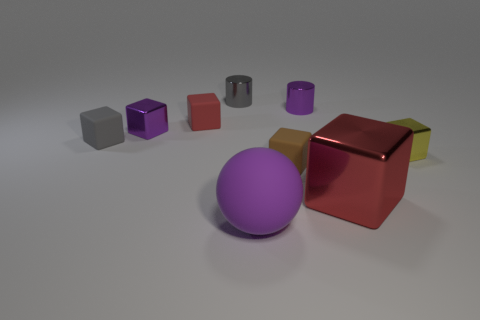Is the big rubber ball the same color as the large metallic thing?
Make the answer very short. No. Are there fewer small gray things that are on the left side of the yellow metallic object than big purple balls?
Ensure brevity in your answer.  No. There is a thing right of the big red metal object; what is its color?
Provide a short and direct response. Yellow. There is a brown rubber thing; what shape is it?
Your answer should be compact. Cube. Is there a small gray matte cube behind the large shiny object on the left side of the tiny cube right of the big cube?
Offer a very short reply. Yes. The metallic block that is in front of the small brown matte object on the right side of the tiny metal cylinder that is to the left of the big ball is what color?
Provide a succinct answer. Red. There is a small brown object that is the same shape as the small yellow metallic object; what is its material?
Make the answer very short. Rubber. What size is the purple shiny cylinder right of the purple metal cube that is behind the tiny brown matte thing?
Your answer should be compact. Small. There is a small block that is in front of the small yellow metallic thing; what is it made of?
Offer a very short reply. Rubber. There is a gray cylinder that is the same material as the large red object; what is its size?
Offer a very short reply. Small. 